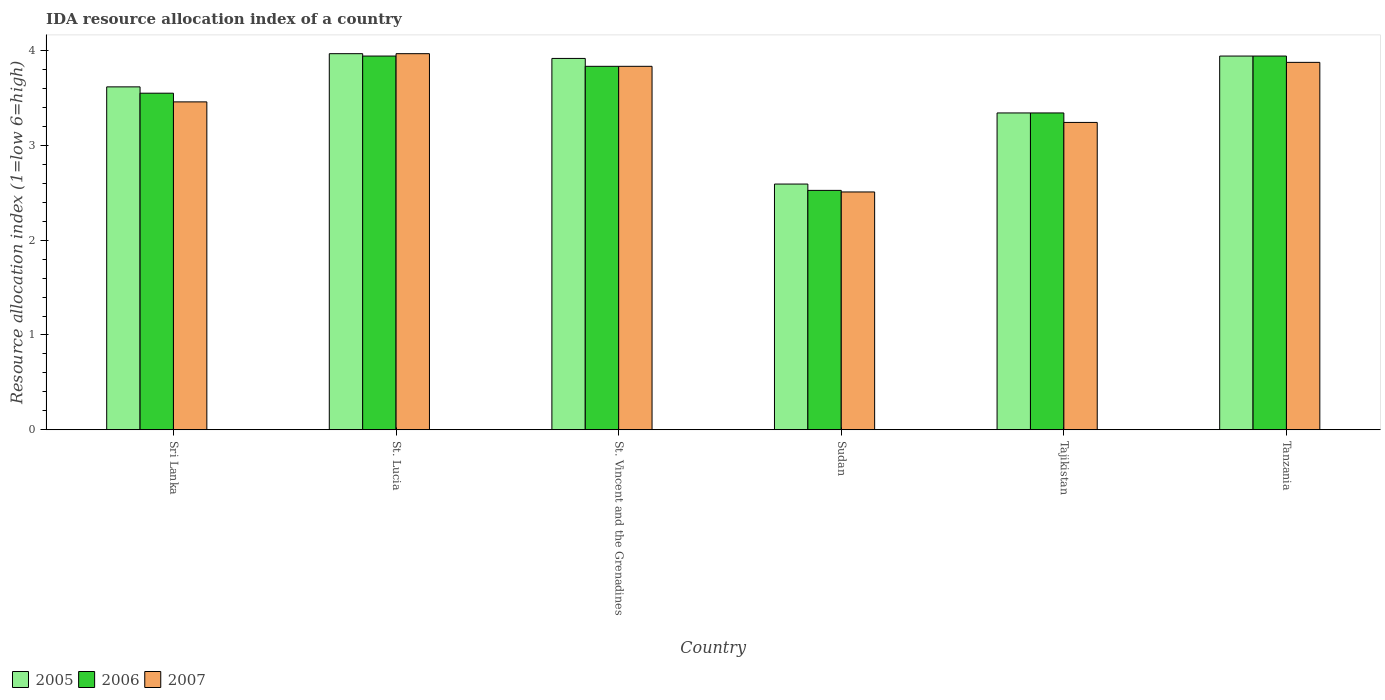How many different coloured bars are there?
Keep it short and to the point. 3. How many bars are there on the 5th tick from the left?
Give a very brief answer. 3. What is the label of the 5th group of bars from the left?
Make the answer very short. Tajikistan. What is the IDA resource allocation index in 2005 in Sudan?
Provide a short and direct response. 2.59. Across all countries, what is the maximum IDA resource allocation index in 2006?
Keep it short and to the point. 3.94. Across all countries, what is the minimum IDA resource allocation index in 2005?
Offer a terse response. 2.59. In which country was the IDA resource allocation index in 2007 maximum?
Your answer should be very brief. St. Lucia. In which country was the IDA resource allocation index in 2006 minimum?
Offer a terse response. Sudan. What is the total IDA resource allocation index in 2007 in the graph?
Provide a succinct answer. 20.88. What is the difference between the IDA resource allocation index in 2005 in St. Vincent and the Grenadines and that in Sudan?
Make the answer very short. 1.33. What is the difference between the IDA resource allocation index in 2007 in Tanzania and the IDA resource allocation index in 2005 in Tajikistan?
Give a very brief answer. 0.53. What is the average IDA resource allocation index in 2006 per country?
Provide a short and direct response. 3.52. What is the difference between the IDA resource allocation index of/in 2007 and IDA resource allocation index of/in 2005 in Sudan?
Offer a terse response. -0.08. What is the ratio of the IDA resource allocation index in 2007 in St. Lucia to that in St. Vincent and the Grenadines?
Provide a short and direct response. 1.03. What is the difference between the highest and the second highest IDA resource allocation index in 2005?
Offer a very short reply. -0.02. What is the difference between the highest and the lowest IDA resource allocation index in 2006?
Give a very brief answer. 1.42. In how many countries, is the IDA resource allocation index in 2007 greater than the average IDA resource allocation index in 2007 taken over all countries?
Your response must be concise. 3. What does the 2nd bar from the right in Sri Lanka represents?
Keep it short and to the point. 2006. Is it the case that in every country, the sum of the IDA resource allocation index in 2006 and IDA resource allocation index in 2007 is greater than the IDA resource allocation index in 2005?
Ensure brevity in your answer.  Yes. Are all the bars in the graph horizontal?
Provide a succinct answer. No. How many countries are there in the graph?
Provide a succinct answer. 6. What is the difference between two consecutive major ticks on the Y-axis?
Your response must be concise. 1. Are the values on the major ticks of Y-axis written in scientific E-notation?
Your answer should be compact. No. Does the graph contain grids?
Keep it short and to the point. No. Where does the legend appear in the graph?
Give a very brief answer. Bottom left. How many legend labels are there?
Provide a short and direct response. 3. What is the title of the graph?
Give a very brief answer. IDA resource allocation index of a country. Does "2005" appear as one of the legend labels in the graph?
Offer a very short reply. Yes. What is the label or title of the Y-axis?
Provide a short and direct response. Resource allocation index (1=low 6=high). What is the Resource allocation index (1=low 6=high) of 2005 in Sri Lanka?
Offer a very short reply. 3.62. What is the Resource allocation index (1=low 6=high) in 2006 in Sri Lanka?
Keep it short and to the point. 3.55. What is the Resource allocation index (1=low 6=high) in 2007 in Sri Lanka?
Give a very brief answer. 3.46. What is the Resource allocation index (1=low 6=high) in 2005 in St. Lucia?
Your response must be concise. 3.97. What is the Resource allocation index (1=low 6=high) of 2006 in St. Lucia?
Your answer should be compact. 3.94. What is the Resource allocation index (1=low 6=high) in 2007 in St. Lucia?
Your response must be concise. 3.97. What is the Resource allocation index (1=low 6=high) in 2005 in St. Vincent and the Grenadines?
Provide a short and direct response. 3.92. What is the Resource allocation index (1=low 6=high) of 2006 in St. Vincent and the Grenadines?
Provide a succinct answer. 3.83. What is the Resource allocation index (1=low 6=high) in 2007 in St. Vincent and the Grenadines?
Your answer should be compact. 3.83. What is the Resource allocation index (1=low 6=high) in 2005 in Sudan?
Ensure brevity in your answer.  2.59. What is the Resource allocation index (1=low 6=high) in 2006 in Sudan?
Make the answer very short. 2.52. What is the Resource allocation index (1=low 6=high) in 2007 in Sudan?
Keep it short and to the point. 2.51. What is the Resource allocation index (1=low 6=high) of 2005 in Tajikistan?
Make the answer very short. 3.34. What is the Resource allocation index (1=low 6=high) of 2006 in Tajikistan?
Provide a succinct answer. 3.34. What is the Resource allocation index (1=low 6=high) in 2007 in Tajikistan?
Give a very brief answer. 3.24. What is the Resource allocation index (1=low 6=high) in 2005 in Tanzania?
Offer a terse response. 3.94. What is the Resource allocation index (1=low 6=high) of 2006 in Tanzania?
Give a very brief answer. 3.94. What is the Resource allocation index (1=low 6=high) in 2007 in Tanzania?
Your answer should be compact. 3.88. Across all countries, what is the maximum Resource allocation index (1=low 6=high) of 2005?
Offer a very short reply. 3.97. Across all countries, what is the maximum Resource allocation index (1=low 6=high) of 2006?
Offer a terse response. 3.94. Across all countries, what is the maximum Resource allocation index (1=low 6=high) in 2007?
Ensure brevity in your answer.  3.97. Across all countries, what is the minimum Resource allocation index (1=low 6=high) in 2005?
Give a very brief answer. 2.59. Across all countries, what is the minimum Resource allocation index (1=low 6=high) in 2006?
Your response must be concise. 2.52. Across all countries, what is the minimum Resource allocation index (1=low 6=high) of 2007?
Offer a very short reply. 2.51. What is the total Resource allocation index (1=low 6=high) of 2005 in the graph?
Offer a very short reply. 21.38. What is the total Resource allocation index (1=low 6=high) in 2006 in the graph?
Your answer should be compact. 21.13. What is the total Resource allocation index (1=low 6=high) in 2007 in the graph?
Provide a succinct answer. 20.88. What is the difference between the Resource allocation index (1=low 6=high) in 2005 in Sri Lanka and that in St. Lucia?
Keep it short and to the point. -0.35. What is the difference between the Resource allocation index (1=low 6=high) of 2006 in Sri Lanka and that in St. Lucia?
Your answer should be very brief. -0.39. What is the difference between the Resource allocation index (1=low 6=high) of 2007 in Sri Lanka and that in St. Lucia?
Your response must be concise. -0.51. What is the difference between the Resource allocation index (1=low 6=high) in 2005 in Sri Lanka and that in St. Vincent and the Grenadines?
Provide a succinct answer. -0.3. What is the difference between the Resource allocation index (1=low 6=high) in 2006 in Sri Lanka and that in St. Vincent and the Grenadines?
Ensure brevity in your answer.  -0.28. What is the difference between the Resource allocation index (1=low 6=high) in 2007 in Sri Lanka and that in St. Vincent and the Grenadines?
Keep it short and to the point. -0.38. What is the difference between the Resource allocation index (1=low 6=high) in 2006 in Sri Lanka and that in Sudan?
Make the answer very short. 1.02. What is the difference between the Resource allocation index (1=low 6=high) of 2005 in Sri Lanka and that in Tajikistan?
Ensure brevity in your answer.  0.28. What is the difference between the Resource allocation index (1=low 6=high) of 2006 in Sri Lanka and that in Tajikistan?
Offer a very short reply. 0.21. What is the difference between the Resource allocation index (1=low 6=high) of 2007 in Sri Lanka and that in Tajikistan?
Provide a short and direct response. 0.22. What is the difference between the Resource allocation index (1=low 6=high) of 2005 in Sri Lanka and that in Tanzania?
Keep it short and to the point. -0.33. What is the difference between the Resource allocation index (1=low 6=high) of 2006 in Sri Lanka and that in Tanzania?
Ensure brevity in your answer.  -0.39. What is the difference between the Resource allocation index (1=low 6=high) in 2007 in Sri Lanka and that in Tanzania?
Offer a very short reply. -0.42. What is the difference between the Resource allocation index (1=low 6=high) of 2005 in St. Lucia and that in St. Vincent and the Grenadines?
Keep it short and to the point. 0.05. What is the difference between the Resource allocation index (1=low 6=high) of 2006 in St. Lucia and that in St. Vincent and the Grenadines?
Offer a very short reply. 0.11. What is the difference between the Resource allocation index (1=low 6=high) of 2007 in St. Lucia and that in St. Vincent and the Grenadines?
Provide a short and direct response. 0.13. What is the difference between the Resource allocation index (1=low 6=high) of 2005 in St. Lucia and that in Sudan?
Your response must be concise. 1.38. What is the difference between the Resource allocation index (1=low 6=high) of 2006 in St. Lucia and that in Sudan?
Your answer should be very brief. 1.42. What is the difference between the Resource allocation index (1=low 6=high) in 2007 in St. Lucia and that in Sudan?
Your response must be concise. 1.46. What is the difference between the Resource allocation index (1=low 6=high) of 2006 in St. Lucia and that in Tajikistan?
Your answer should be compact. 0.6. What is the difference between the Resource allocation index (1=low 6=high) in 2007 in St. Lucia and that in Tajikistan?
Keep it short and to the point. 0.72. What is the difference between the Resource allocation index (1=low 6=high) in 2005 in St. Lucia and that in Tanzania?
Provide a succinct answer. 0.03. What is the difference between the Resource allocation index (1=low 6=high) of 2006 in St. Lucia and that in Tanzania?
Provide a succinct answer. 0. What is the difference between the Resource allocation index (1=low 6=high) in 2007 in St. Lucia and that in Tanzania?
Make the answer very short. 0.09. What is the difference between the Resource allocation index (1=low 6=high) of 2005 in St. Vincent and the Grenadines and that in Sudan?
Offer a very short reply. 1.32. What is the difference between the Resource allocation index (1=low 6=high) in 2006 in St. Vincent and the Grenadines and that in Sudan?
Make the answer very short. 1.31. What is the difference between the Resource allocation index (1=low 6=high) of 2007 in St. Vincent and the Grenadines and that in Sudan?
Make the answer very short. 1.32. What is the difference between the Resource allocation index (1=low 6=high) in 2005 in St. Vincent and the Grenadines and that in Tajikistan?
Give a very brief answer. 0.57. What is the difference between the Resource allocation index (1=low 6=high) of 2006 in St. Vincent and the Grenadines and that in Tajikistan?
Give a very brief answer. 0.49. What is the difference between the Resource allocation index (1=low 6=high) in 2007 in St. Vincent and the Grenadines and that in Tajikistan?
Keep it short and to the point. 0.59. What is the difference between the Resource allocation index (1=low 6=high) of 2005 in St. Vincent and the Grenadines and that in Tanzania?
Your answer should be very brief. -0.03. What is the difference between the Resource allocation index (1=low 6=high) of 2006 in St. Vincent and the Grenadines and that in Tanzania?
Offer a very short reply. -0.11. What is the difference between the Resource allocation index (1=low 6=high) of 2007 in St. Vincent and the Grenadines and that in Tanzania?
Provide a short and direct response. -0.04. What is the difference between the Resource allocation index (1=low 6=high) of 2005 in Sudan and that in Tajikistan?
Your answer should be very brief. -0.75. What is the difference between the Resource allocation index (1=low 6=high) of 2006 in Sudan and that in Tajikistan?
Provide a succinct answer. -0.82. What is the difference between the Resource allocation index (1=low 6=high) of 2007 in Sudan and that in Tajikistan?
Make the answer very short. -0.73. What is the difference between the Resource allocation index (1=low 6=high) of 2005 in Sudan and that in Tanzania?
Offer a terse response. -1.35. What is the difference between the Resource allocation index (1=low 6=high) of 2006 in Sudan and that in Tanzania?
Keep it short and to the point. -1.42. What is the difference between the Resource allocation index (1=low 6=high) in 2007 in Sudan and that in Tanzania?
Give a very brief answer. -1.37. What is the difference between the Resource allocation index (1=low 6=high) of 2006 in Tajikistan and that in Tanzania?
Provide a short and direct response. -0.6. What is the difference between the Resource allocation index (1=low 6=high) of 2007 in Tajikistan and that in Tanzania?
Your answer should be very brief. -0.63. What is the difference between the Resource allocation index (1=low 6=high) in 2005 in Sri Lanka and the Resource allocation index (1=low 6=high) in 2006 in St. Lucia?
Keep it short and to the point. -0.33. What is the difference between the Resource allocation index (1=low 6=high) of 2005 in Sri Lanka and the Resource allocation index (1=low 6=high) of 2007 in St. Lucia?
Offer a very short reply. -0.35. What is the difference between the Resource allocation index (1=low 6=high) in 2006 in Sri Lanka and the Resource allocation index (1=low 6=high) in 2007 in St. Lucia?
Keep it short and to the point. -0.42. What is the difference between the Resource allocation index (1=low 6=high) in 2005 in Sri Lanka and the Resource allocation index (1=low 6=high) in 2006 in St. Vincent and the Grenadines?
Ensure brevity in your answer.  -0.22. What is the difference between the Resource allocation index (1=low 6=high) in 2005 in Sri Lanka and the Resource allocation index (1=low 6=high) in 2007 in St. Vincent and the Grenadines?
Provide a succinct answer. -0.22. What is the difference between the Resource allocation index (1=low 6=high) in 2006 in Sri Lanka and the Resource allocation index (1=low 6=high) in 2007 in St. Vincent and the Grenadines?
Give a very brief answer. -0.28. What is the difference between the Resource allocation index (1=low 6=high) in 2005 in Sri Lanka and the Resource allocation index (1=low 6=high) in 2006 in Sudan?
Offer a very short reply. 1.09. What is the difference between the Resource allocation index (1=low 6=high) of 2005 in Sri Lanka and the Resource allocation index (1=low 6=high) of 2007 in Sudan?
Provide a short and direct response. 1.11. What is the difference between the Resource allocation index (1=low 6=high) of 2006 in Sri Lanka and the Resource allocation index (1=low 6=high) of 2007 in Sudan?
Ensure brevity in your answer.  1.04. What is the difference between the Resource allocation index (1=low 6=high) in 2005 in Sri Lanka and the Resource allocation index (1=low 6=high) in 2006 in Tajikistan?
Make the answer very short. 0.28. What is the difference between the Resource allocation index (1=low 6=high) in 2005 in Sri Lanka and the Resource allocation index (1=low 6=high) in 2007 in Tajikistan?
Keep it short and to the point. 0.38. What is the difference between the Resource allocation index (1=low 6=high) in 2006 in Sri Lanka and the Resource allocation index (1=low 6=high) in 2007 in Tajikistan?
Offer a very short reply. 0.31. What is the difference between the Resource allocation index (1=low 6=high) in 2005 in Sri Lanka and the Resource allocation index (1=low 6=high) in 2006 in Tanzania?
Your response must be concise. -0.33. What is the difference between the Resource allocation index (1=low 6=high) in 2005 in Sri Lanka and the Resource allocation index (1=low 6=high) in 2007 in Tanzania?
Offer a very short reply. -0.26. What is the difference between the Resource allocation index (1=low 6=high) of 2006 in Sri Lanka and the Resource allocation index (1=low 6=high) of 2007 in Tanzania?
Provide a succinct answer. -0.33. What is the difference between the Resource allocation index (1=low 6=high) of 2005 in St. Lucia and the Resource allocation index (1=low 6=high) of 2006 in St. Vincent and the Grenadines?
Ensure brevity in your answer.  0.13. What is the difference between the Resource allocation index (1=low 6=high) of 2005 in St. Lucia and the Resource allocation index (1=low 6=high) of 2007 in St. Vincent and the Grenadines?
Your response must be concise. 0.13. What is the difference between the Resource allocation index (1=low 6=high) of 2006 in St. Lucia and the Resource allocation index (1=low 6=high) of 2007 in St. Vincent and the Grenadines?
Provide a succinct answer. 0.11. What is the difference between the Resource allocation index (1=low 6=high) in 2005 in St. Lucia and the Resource allocation index (1=low 6=high) in 2006 in Sudan?
Ensure brevity in your answer.  1.44. What is the difference between the Resource allocation index (1=low 6=high) of 2005 in St. Lucia and the Resource allocation index (1=low 6=high) of 2007 in Sudan?
Provide a short and direct response. 1.46. What is the difference between the Resource allocation index (1=low 6=high) in 2006 in St. Lucia and the Resource allocation index (1=low 6=high) in 2007 in Sudan?
Provide a short and direct response. 1.43. What is the difference between the Resource allocation index (1=low 6=high) of 2005 in St. Lucia and the Resource allocation index (1=low 6=high) of 2007 in Tajikistan?
Give a very brief answer. 0.72. What is the difference between the Resource allocation index (1=low 6=high) in 2005 in St. Lucia and the Resource allocation index (1=low 6=high) in 2006 in Tanzania?
Your answer should be compact. 0.03. What is the difference between the Resource allocation index (1=low 6=high) of 2005 in St. Lucia and the Resource allocation index (1=low 6=high) of 2007 in Tanzania?
Make the answer very short. 0.09. What is the difference between the Resource allocation index (1=low 6=high) of 2006 in St. Lucia and the Resource allocation index (1=low 6=high) of 2007 in Tanzania?
Provide a succinct answer. 0.07. What is the difference between the Resource allocation index (1=low 6=high) in 2005 in St. Vincent and the Grenadines and the Resource allocation index (1=low 6=high) in 2006 in Sudan?
Your answer should be compact. 1.39. What is the difference between the Resource allocation index (1=low 6=high) in 2005 in St. Vincent and the Grenadines and the Resource allocation index (1=low 6=high) in 2007 in Sudan?
Offer a terse response. 1.41. What is the difference between the Resource allocation index (1=low 6=high) in 2006 in St. Vincent and the Grenadines and the Resource allocation index (1=low 6=high) in 2007 in Sudan?
Provide a short and direct response. 1.32. What is the difference between the Resource allocation index (1=low 6=high) of 2005 in St. Vincent and the Grenadines and the Resource allocation index (1=low 6=high) of 2006 in Tajikistan?
Provide a short and direct response. 0.57. What is the difference between the Resource allocation index (1=low 6=high) in 2005 in St. Vincent and the Grenadines and the Resource allocation index (1=low 6=high) in 2007 in Tajikistan?
Provide a succinct answer. 0.68. What is the difference between the Resource allocation index (1=low 6=high) of 2006 in St. Vincent and the Grenadines and the Resource allocation index (1=low 6=high) of 2007 in Tajikistan?
Your answer should be compact. 0.59. What is the difference between the Resource allocation index (1=low 6=high) of 2005 in St. Vincent and the Grenadines and the Resource allocation index (1=low 6=high) of 2006 in Tanzania?
Your response must be concise. -0.03. What is the difference between the Resource allocation index (1=low 6=high) of 2005 in St. Vincent and the Grenadines and the Resource allocation index (1=low 6=high) of 2007 in Tanzania?
Offer a very short reply. 0.04. What is the difference between the Resource allocation index (1=low 6=high) in 2006 in St. Vincent and the Grenadines and the Resource allocation index (1=low 6=high) in 2007 in Tanzania?
Your response must be concise. -0.04. What is the difference between the Resource allocation index (1=low 6=high) in 2005 in Sudan and the Resource allocation index (1=low 6=high) in 2006 in Tajikistan?
Ensure brevity in your answer.  -0.75. What is the difference between the Resource allocation index (1=low 6=high) in 2005 in Sudan and the Resource allocation index (1=low 6=high) in 2007 in Tajikistan?
Your answer should be very brief. -0.65. What is the difference between the Resource allocation index (1=low 6=high) of 2006 in Sudan and the Resource allocation index (1=low 6=high) of 2007 in Tajikistan?
Your response must be concise. -0.72. What is the difference between the Resource allocation index (1=low 6=high) in 2005 in Sudan and the Resource allocation index (1=low 6=high) in 2006 in Tanzania?
Offer a very short reply. -1.35. What is the difference between the Resource allocation index (1=low 6=high) in 2005 in Sudan and the Resource allocation index (1=low 6=high) in 2007 in Tanzania?
Your response must be concise. -1.28. What is the difference between the Resource allocation index (1=low 6=high) of 2006 in Sudan and the Resource allocation index (1=low 6=high) of 2007 in Tanzania?
Offer a very short reply. -1.35. What is the difference between the Resource allocation index (1=low 6=high) of 2005 in Tajikistan and the Resource allocation index (1=low 6=high) of 2006 in Tanzania?
Your answer should be very brief. -0.6. What is the difference between the Resource allocation index (1=low 6=high) in 2005 in Tajikistan and the Resource allocation index (1=low 6=high) in 2007 in Tanzania?
Provide a succinct answer. -0.53. What is the difference between the Resource allocation index (1=low 6=high) in 2006 in Tajikistan and the Resource allocation index (1=low 6=high) in 2007 in Tanzania?
Offer a terse response. -0.53. What is the average Resource allocation index (1=low 6=high) in 2005 per country?
Provide a succinct answer. 3.56. What is the average Resource allocation index (1=low 6=high) of 2006 per country?
Provide a succinct answer. 3.52. What is the average Resource allocation index (1=low 6=high) of 2007 per country?
Ensure brevity in your answer.  3.48. What is the difference between the Resource allocation index (1=low 6=high) of 2005 and Resource allocation index (1=low 6=high) of 2006 in Sri Lanka?
Your response must be concise. 0.07. What is the difference between the Resource allocation index (1=low 6=high) in 2005 and Resource allocation index (1=low 6=high) in 2007 in Sri Lanka?
Keep it short and to the point. 0.16. What is the difference between the Resource allocation index (1=low 6=high) in 2006 and Resource allocation index (1=low 6=high) in 2007 in Sri Lanka?
Offer a very short reply. 0.09. What is the difference between the Resource allocation index (1=low 6=high) in 2005 and Resource allocation index (1=low 6=high) in 2006 in St. Lucia?
Ensure brevity in your answer.  0.03. What is the difference between the Resource allocation index (1=low 6=high) in 2006 and Resource allocation index (1=low 6=high) in 2007 in St. Lucia?
Give a very brief answer. -0.03. What is the difference between the Resource allocation index (1=low 6=high) in 2005 and Resource allocation index (1=low 6=high) in 2006 in St. Vincent and the Grenadines?
Keep it short and to the point. 0.08. What is the difference between the Resource allocation index (1=low 6=high) of 2005 and Resource allocation index (1=low 6=high) of 2007 in St. Vincent and the Grenadines?
Offer a very short reply. 0.08. What is the difference between the Resource allocation index (1=low 6=high) of 2006 and Resource allocation index (1=low 6=high) of 2007 in St. Vincent and the Grenadines?
Offer a terse response. 0. What is the difference between the Resource allocation index (1=low 6=high) in 2005 and Resource allocation index (1=low 6=high) in 2006 in Sudan?
Give a very brief answer. 0.07. What is the difference between the Resource allocation index (1=low 6=high) of 2005 and Resource allocation index (1=low 6=high) of 2007 in Sudan?
Offer a terse response. 0.08. What is the difference between the Resource allocation index (1=low 6=high) in 2006 and Resource allocation index (1=low 6=high) in 2007 in Sudan?
Give a very brief answer. 0.02. What is the difference between the Resource allocation index (1=low 6=high) of 2005 and Resource allocation index (1=low 6=high) of 2006 in Tajikistan?
Your response must be concise. 0. What is the difference between the Resource allocation index (1=low 6=high) in 2005 and Resource allocation index (1=low 6=high) in 2007 in Tajikistan?
Give a very brief answer. 0.1. What is the difference between the Resource allocation index (1=low 6=high) in 2005 and Resource allocation index (1=low 6=high) in 2006 in Tanzania?
Provide a succinct answer. 0. What is the difference between the Resource allocation index (1=low 6=high) of 2005 and Resource allocation index (1=low 6=high) of 2007 in Tanzania?
Offer a very short reply. 0.07. What is the difference between the Resource allocation index (1=low 6=high) of 2006 and Resource allocation index (1=low 6=high) of 2007 in Tanzania?
Your response must be concise. 0.07. What is the ratio of the Resource allocation index (1=low 6=high) in 2005 in Sri Lanka to that in St. Lucia?
Your answer should be very brief. 0.91. What is the ratio of the Resource allocation index (1=low 6=high) of 2006 in Sri Lanka to that in St. Lucia?
Your answer should be compact. 0.9. What is the ratio of the Resource allocation index (1=low 6=high) in 2007 in Sri Lanka to that in St. Lucia?
Offer a very short reply. 0.87. What is the ratio of the Resource allocation index (1=low 6=high) in 2005 in Sri Lanka to that in St. Vincent and the Grenadines?
Provide a succinct answer. 0.92. What is the ratio of the Resource allocation index (1=low 6=high) in 2006 in Sri Lanka to that in St. Vincent and the Grenadines?
Your response must be concise. 0.93. What is the ratio of the Resource allocation index (1=low 6=high) of 2007 in Sri Lanka to that in St. Vincent and the Grenadines?
Your answer should be very brief. 0.9. What is the ratio of the Resource allocation index (1=low 6=high) of 2005 in Sri Lanka to that in Sudan?
Provide a succinct answer. 1.4. What is the ratio of the Resource allocation index (1=low 6=high) in 2006 in Sri Lanka to that in Sudan?
Your answer should be very brief. 1.41. What is the ratio of the Resource allocation index (1=low 6=high) of 2007 in Sri Lanka to that in Sudan?
Keep it short and to the point. 1.38. What is the ratio of the Resource allocation index (1=low 6=high) in 2005 in Sri Lanka to that in Tajikistan?
Keep it short and to the point. 1.08. What is the ratio of the Resource allocation index (1=low 6=high) in 2006 in Sri Lanka to that in Tajikistan?
Make the answer very short. 1.06. What is the ratio of the Resource allocation index (1=low 6=high) in 2007 in Sri Lanka to that in Tajikistan?
Keep it short and to the point. 1.07. What is the ratio of the Resource allocation index (1=low 6=high) of 2005 in Sri Lanka to that in Tanzania?
Give a very brief answer. 0.92. What is the ratio of the Resource allocation index (1=low 6=high) of 2006 in Sri Lanka to that in Tanzania?
Your response must be concise. 0.9. What is the ratio of the Resource allocation index (1=low 6=high) in 2007 in Sri Lanka to that in Tanzania?
Offer a terse response. 0.89. What is the ratio of the Resource allocation index (1=low 6=high) in 2005 in St. Lucia to that in St. Vincent and the Grenadines?
Keep it short and to the point. 1.01. What is the ratio of the Resource allocation index (1=low 6=high) in 2006 in St. Lucia to that in St. Vincent and the Grenadines?
Give a very brief answer. 1.03. What is the ratio of the Resource allocation index (1=low 6=high) in 2007 in St. Lucia to that in St. Vincent and the Grenadines?
Provide a short and direct response. 1.03. What is the ratio of the Resource allocation index (1=low 6=high) in 2005 in St. Lucia to that in Sudan?
Your answer should be compact. 1.53. What is the ratio of the Resource allocation index (1=low 6=high) of 2006 in St. Lucia to that in Sudan?
Make the answer very short. 1.56. What is the ratio of the Resource allocation index (1=low 6=high) of 2007 in St. Lucia to that in Sudan?
Keep it short and to the point. 1.58. What is the ratio of the Resource allocation index (1=low 6=high) in 2005 in St. Lucia to that in Tajikistan?
Provide a short and direct response. 1.19. What is the ratio of the Resource allocation index (1=low 6=high) of 2006 in St. Lucia to that in Tajikistan?
Make the answer very short. 1.18. What is the ratio of the Resource allocation index (1=low 6=high) of 2007 in St. Lucia to that in Tajikistan?
Your answer should be compact. 1.22. What is the ratio of the Resource allocation index (1=low 6=high) of 2006 in St. Lucia to that in Tanzania?
Offer a very short reply. 1. What is the ratio of the Resource allocation index (1=low 6=high) of 2007 in St. Lucia to that in Tanzania?
Your answer should be very brief. 1.02. What is the ratio of the Resource allocation index (1=low 6=high) in 2005 in St. Vincent and the Grenadines to that in Sudan?
Give a very brief answer. 1.51. What is the ratio of the Resource allocation index (1=low 6=high) of 2006 in St. Vincent and the Grenadines to that in Sudan?
Your answer should be very brief. 1.52. What is the ratio of the Resource allocation index (1=low 6=high) in 2007 in St. Vincent and the Grenadines to that in Sudan?
Offer a very short reply. 1.53. What is the ratio of the Resource allocation index (1=low 6=high) in 2005 in St. Vincent and the Grenadines to that in Tajikistan?
Keep it short and to the point. 1.17. What is the ratio of the Resource allocation index (1=low 6=high) in 2006 in St. Vincent and the Grenadines to that in Tajikistan?
Provide a succinct answer. 1.15. What is the ratio of the Resource allocation index (1=low 6=high) of 2007 in St. Vincent and the Grenadines to that in Tajikistan?
Your answer should be compact. 1.18. What is the ratio of the Resource allocation index (1=low 6=high) of 2006 in St. Vincent and the Grenadines to that in Tanzania?
Your response must be concise. 0.97. What is the ratio of the Resource allocation index (1=low 6=high) of 2007 in St. Vincent and the Grenadines to that in Tanzania?
Offer a very short reply. 0.99. What is the ratio of the Resource allocation index (1=low 6=high) of 2005 in Sudan to that in Tajikistan?
Make the answer very short. 0.78. What is the ratio of the Resource allocation index (1=low 6=high) in 2006 in Sudan to that in Tajikistan?
Your answer should be very brief. 0.76. What is the ratio of the Resource allocation index (1=low 6=high) in 2007 in Sudan to that in Tajikistan?
Give a very brief answer. 0.77. What is the ratio of the Resource allocation index (1=low 6=high) in 2005 in Sudan to that in Tanzania?
Offer a terse response. 0.66. What is the ratio of the Resource allocation index (1=low 6=high) in 2006 in Sudan to that in Tanzania?
Provide a short and direct response. 0.64. What is the ratio of the Resource allocation index (1=low 6=high) in 2007 in Sudan to that in Tanzania?
Keep it short and to the point. 0.65. What is the ratio of the Resource allocation index (1=low 6=high) of 2005 in Tajikistan to that in Tanzania?
Give a very brief answer. 0.85. What is the ratio of the Resource allocation index (1=low 6=high) in 2006 in Tajikistan to that in Tanzania?
Give a very brief answer. 0.85. What is the ratio of the Resource allocation index (1=low 6=high) in 2007 in Tajikistan to that in Tanzania?
Provide a succinct answer. 0.84. What is the difference between the highest and the second highest Resource allocation index (1=low 6=high) of 2005?
Give a very brief answer. 0.03. What is the difference between the highest and the second highest Resource allocation index (1=low 6=high) in 2006?
Offer a very short reply. 0. What is the difference between the highest and the second highest Resource allocation index (1=low 6=high) of 2007?
Your answer should be compact. 0.09. What is the difference between the highest and the lowest Resource allocation index (1=low 6=high) in 2005?
Your answer should be compact. 1.38. What is the difference between the highest and the lowest Resource allocation index (1=low 6=high) of 2006?
Ensure brevity in your answer.  1.42. What is the difference between the highest and the lowest Resource allocation index (1=low 6=high) of 2007?
Ensure brevity in your answer.  1.46. 